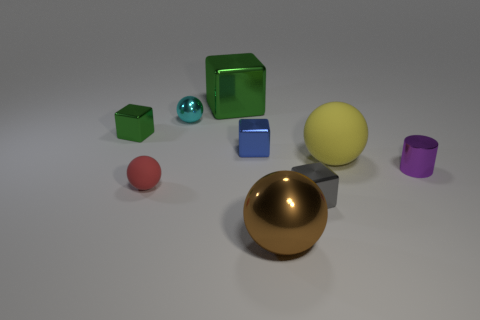What number of objects are either small blue blocks or big gray cubes?
Your answer should be very brief. 1. There is a small object that is behind the tiny metallic block behind the blue cube; what shape is it?
Your answer should be compact. Sphere. How many other objects are the same material as the small green cube?
Provide a succinct answer. 6. Is the red object made of the same material as the object that is behind the small cyan metal sphere?
Ensure brevity in your answer.  No. What number of objects are small metal things that are in front of the yellow object or small objects that are in front of the tiny blue metal block?
Your answer should be very brief. 3. What number of other objects are there of the same color as the small rubber object?
Offer a terse response. 0. Are there more metal balls behind the small red sphere than green things that are on the right side of the cyan metallic sphere?
Ensure brevity in your answer.  No. How many cylinders are either brown objects or green shiny objects?
Give a very brief answer. 0. What number of objects are either tiny blocks in front of the tiny rubber object or big brown metallic balls?
Your answer should be very brief. 2. There is a big shiny thing behind the large shiny object in front of the large metal thing that is behind the cyan thing; what is its shape?
Give a very brief answer. Cube. 